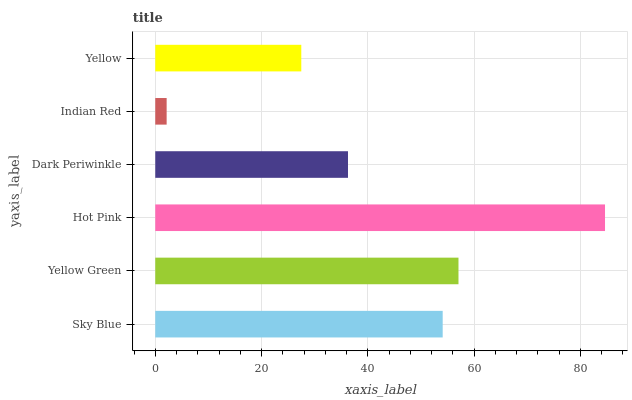Is Indian Red the minimum?
Answer yes or no. Yes. Is Hot Pink the maximum?
Answer yes or no. Yes. Is Yellow Green the minimum?
Answer yes or no. No. Is Yellow Green the maximum?
Answer yes or no. No. Is Yellow Green greater than Sky Blue?
Answer yes or no. Yes. Is Sky Blue less than Yellow Green?
Answer yes or no. Yes. Is Sky Blue greater than Yellow Green?
Answer yes or no. No. Is Yellow Green less than Sky Blue?
Answer yes or no. No. Is Sky Blue the high median?
Answer yes or no. Yes. Is Dark Periwinkle the low median?
Answer yes or no. Yes. Is Hot Pink the high median?
Answer yes or no. No. Is Sky Blue the low median?
Answer yes or no. No. 